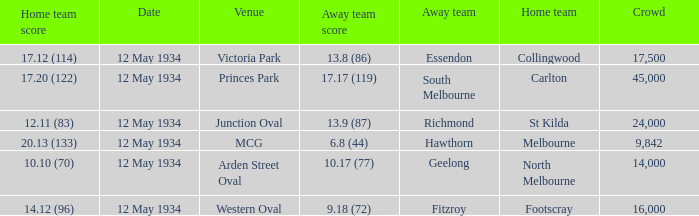What was the score of the away team while playing at the arden street oval? 10.17 (77). 